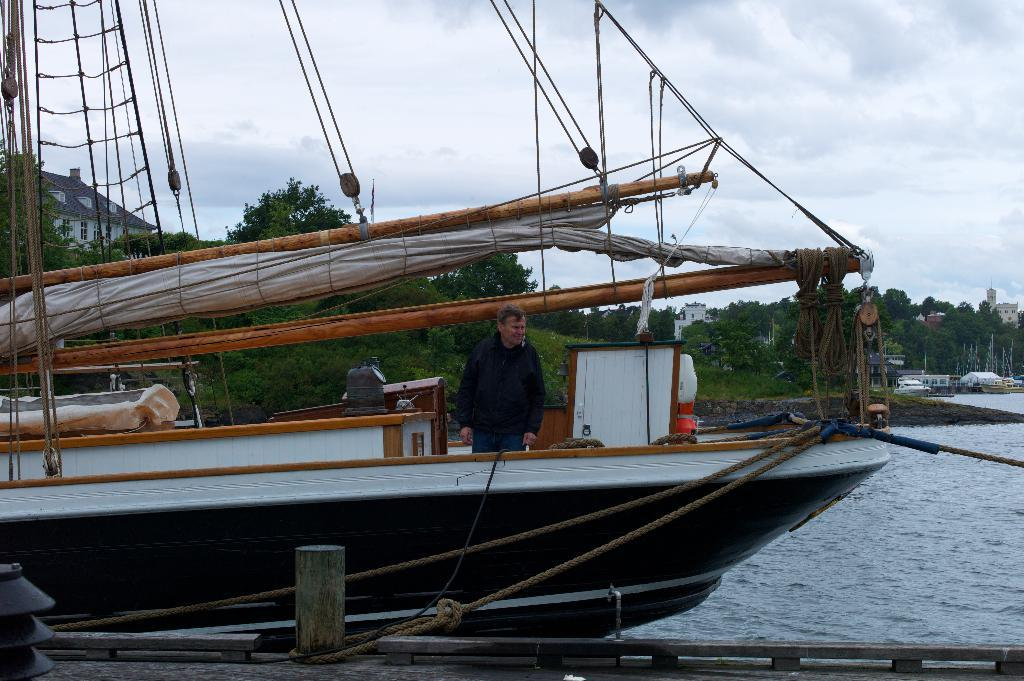What is the man in the image doing? The man is standing on a boat in the image. What can be seen in the background of the image? There are trees and water visible in the background of the image. What is located on the right side of the image? There are buildings and boats on the right side of the image. What type of bead is being used as a decoration on the boat in the image? There is no bead present as a decoration on the boat in the image. How many pigs are visible on the boat in the image? There are no pigs present on the boat in the image. 